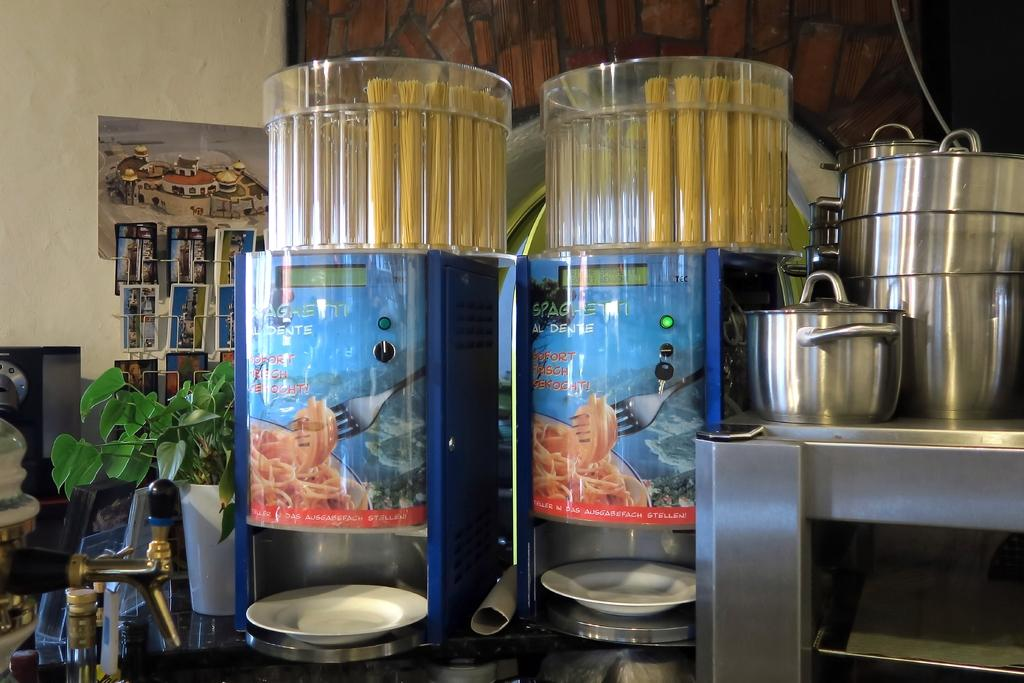<image>
Create a compact narrative representing the image presented. Two machines that cooks Spaghetti Al Dente sit on a counter. 